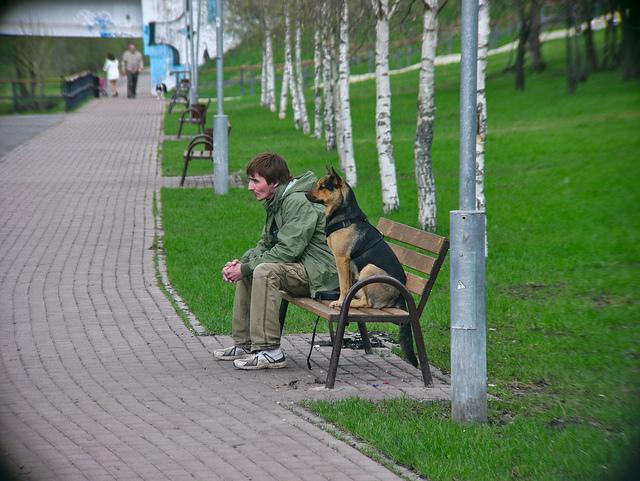What is the black strap hanging from the bench called? leash 